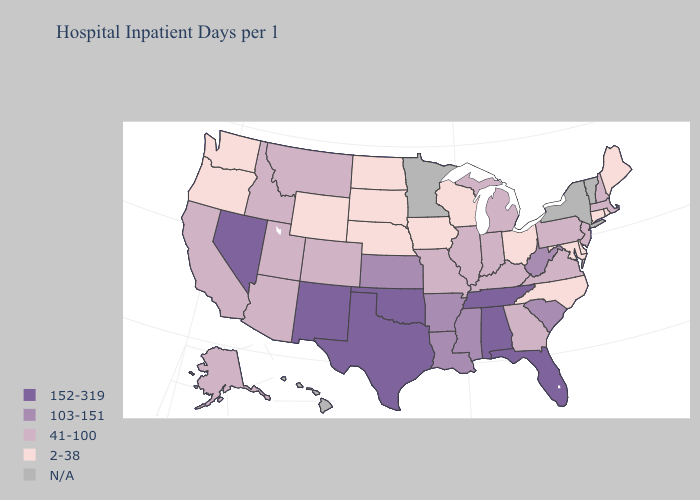What is the lowest value in states that border Texas?
Be succinct. 103-151. Name the states that have a value in the range 41-100?
Concise answer only. Alaska, Arizona, California, Colorado, Georgia, Idaho, Illinois, Indiana, Kentucky, Massachusetts, Michigan, Missouri, Montana, New Hampshire, New Jersey, Pennsylvania, Utah, Virginia. What is the highest value in states that border Florida?
Keep it brief. 152-319. What is the value of Rhode Island?
Give a very brief answer. 2-38. Which states hav the highest value in the MidWest?
Write a very short answer. Kansas. Name the states that have a value in the range 2-38?
Give a very brief answer. Connecticut, Delaware, Iowa, Maine, Maryland, Nebraska, North Carolina, North Dakota, Ohio, Oregon, Rhode Island, South Dakota, Washington, Wisconsin, Wyoming. Which states have the lowest value in the USA?
Concise answer only. Connecticut, Delaware, Iowa, Maine, Maryland, Nebraska, North Carolina, North Dakota, Ohio, Oregon, Rhode Island, South Dakota, Washington, Wisconsin, Wyoming. Among the states that border New Mexico , which have the highest value?
Short answer required. Oklahoma, Texas. Name the states that have a value in the range 103-151?
Concise answer only. Arkansas, Kansas, Louisiana, Mississippi, South Carolina, West Virginia. What is the lowest value in the MidWest?
Be succinct. 2-38. How many symbols are there in the legend?
Give a very brief answer. 5. What is the value of Kansas?
Give a very brief answer. 103-151. Which states have the highest value in the USA?
Give a very brief answer. Alabama, Florida, Nevada, New Mexico, Oklahoma, Tennessee, Texas. What is the value of Alaska?
Answer briefly. 41-100. Which states hav the highest value in the South?
Be succinct. Alabama, Florida, Oklahoma, Tennessee, Texas. 